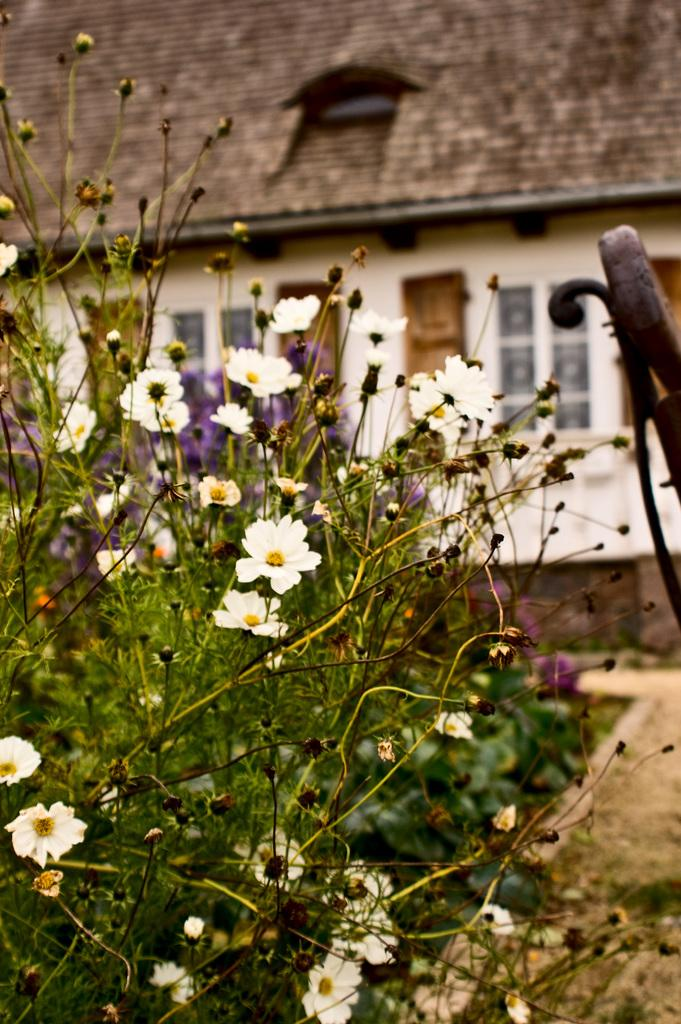What type of plants are in the image? There are plants with white flowers in the image. What structure can be seen in the image? There is a building in the image. What feature of the building is mentioned in the facts? The building has windows and roof tiles. Can you see your friend standing next to the building in the image? The image does not show any friends or people standing next to the building. What point is being made by the plants with white flowers in the image? The image does not convey any specific point or message through the plants with white flowers. 